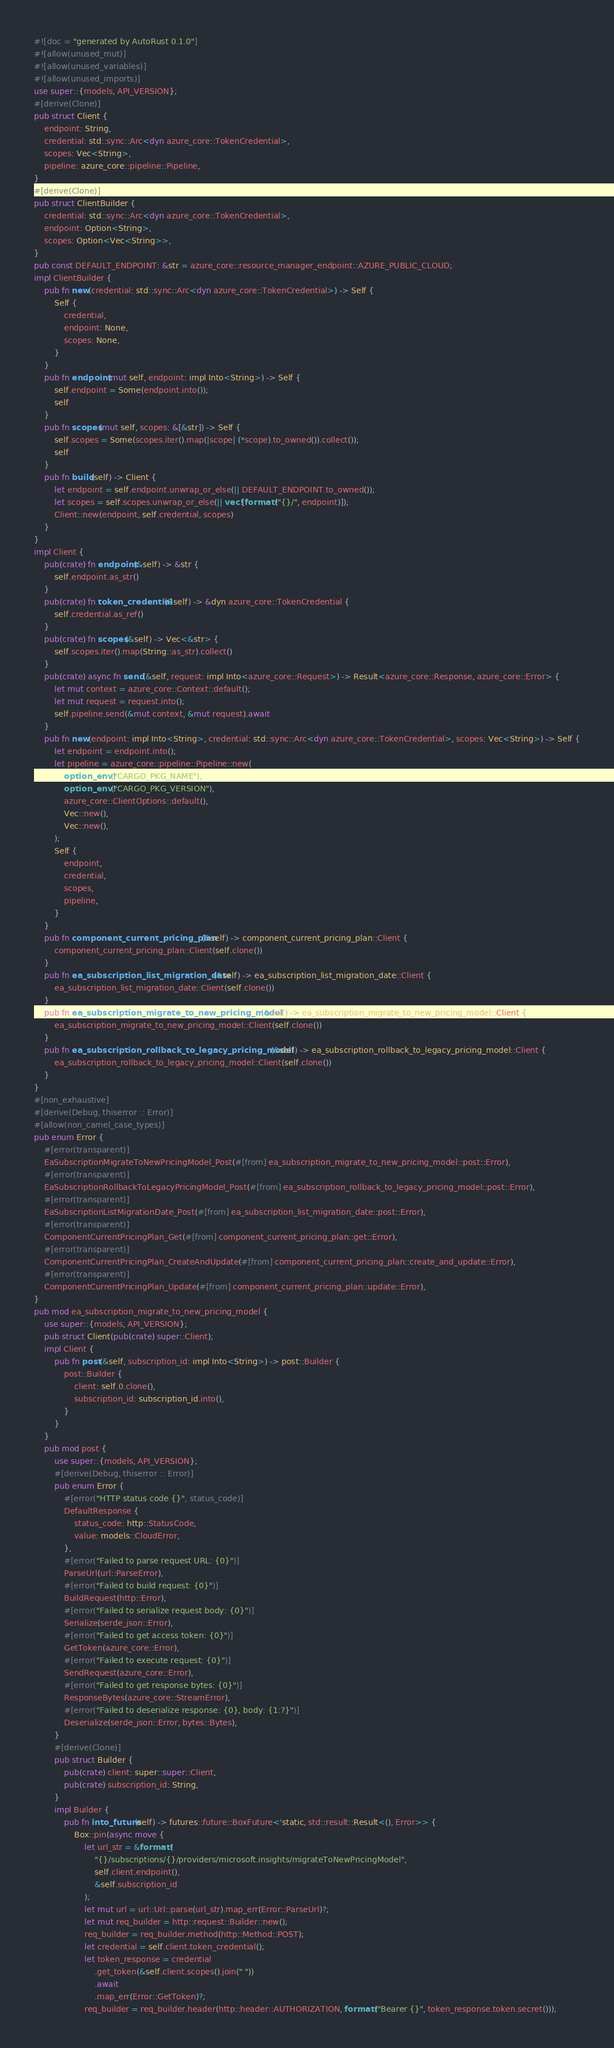<code> <loc_0><loc_0><loc_500><loc_500><_Rust_>#![doc = "generated by AutoRust 0.1.0"]
#![allow(unused_mut)]
#![allow(unused_variables)]
#![allow(unused_imports)]
use super::{models, API_VERSION};
#[derive(Clone)]
pub struct Client {
    endpoint: String,
    credential: std::sync::Arc<dyn azure_core::TokenCredential>,
    scopes: Vec<String>,
    pipeline: azure_core::pipeline::Pipeline,
}
#[derive(Clone)]
pub struct ClientBuilder {
    credential: std::sync::Arc<dyn azure_core::TokenCredential>,
    endpoint: Option<String>,
    scopes: Option<Vec<String>>,
}
pub const DEFAULT_ENDPOINT: &str = azure_core::resource_manager_endpoint::AZURE_PUBLIC_CLOUD;
impl ClientBuilder {
    pub fn new(credential: std::sync::Arc<dyn azure_core::TokenCredential>) -> Self {
        Self {
            credential,
            endpoint: None,
            scopes: None,
        }
    }
    pub fn endpoint(mut self, endpoint: impl Into<String>) -> Self {
        self.endpoint = Some(endpoint.into());
        self
    }
    pub fn scopes(mut self, scopes: &[&str]) -> Self {
        self.scopes = Some(scopes.iter().map(|scope| (*scope).to_owned()).collect());
        self
    }
    pub fn build(self) -> Client {
        let endpoint = self.endpoint.unwrap_or_else(|| DEFAULT_ENDPOINT.to_owned());
        let scopes = self.scopes.unwrap_or_else(|| vec![format!("{}/", endpoint)]);
        Client::new(endpoint, self.credential, scopes)
    }
}
impl Client {
    pub(crate) fn endpoint(&self) -> &str {
        self.endpoint.as_str()
    }
    pub(crate) fn token_credential(&self) -> &dyn azure_core::TokenCredential {
        self.credential.as_ref()
    }
    pub(crate) fn scopes(&self) -> Vec<&str> {
        self.scopes.iter().map(String::as_str).collect()
    }
    pub(crate) async fn send(&self, request: impl Into<azure_core::Request>) -> Result<azure_core::Response, azure_core::Error> {
        let mut context = azure_core::Context::default();
        let mut request = request.into();
        self.pipeline.send(&mut context, &mut request).await
    }
    pub fn new(endpoint: impl Into<String>, credential: std::sync::Arc<dyn azure_core::TokenCredential>, scopes: Vec<String>) -> Self {
        let endpoint = endpoint.into();
        let pipeline = azure_core::pipeline::Pipeline::new(
            option_env!("CARGO_PKG_NAME"),
            option_env!("CARGO_PKG_VERSION"),
            azure_core::ClientOptions::default(),
            Vec::new(),
            Vec::new(),
        );
        Self {
            endpoint,
            credential,
            scopes,
            pipeline,
        }
    }
    pub fn component_current_pricing_plan(&self) -> component_current_pricing_plan::Client {
        component_current_pricing_plan::Client(self.clone())
    }
    pub fn ea_subscription_list_migration_date(&self) -> ea_subscription_list_migration_date::Client {
        ea_subscription_list_migration_date::Client(self.clone())
    }
    pub fn ea_subscription_migrate_to_new_pricing_model(&self) -> ea_subscription_migrate_to_new_pricing_model::Client {
        ea_subscription_migrate_to_new_pricing_model::Client(self.clone())
    }
    pub fn ea_subscription_rollback_to_legacy_pricing_model(&self) -> ea_subscription_rollback_to_legacy_pricing_model::Client {
        ea_subscription_rollback_to_legacy_pricing_model::Client(self.clone())
    }
}
#[non_exhaustive]
#[derive(Debug, thiserror :: Error)]
#[allow(non_camel_case_types)]
pub enum Error {
    #[error(transparent)]
    EaSubscriptionMigrateToNewPricingModel_Post(#[from] ea_subscription_migrate_to_new_pricing_model::post::Error),
    #[error(transparent)]
    EaSubscriptionRollbackToLegacyPricingModel_Post(#[from] ea_subscription_rollback_to_legacy_pricing_model::post::Error),
    #[error(transparent)]
    EaSubscriptionListMigrationDate_Post(#[from] ea_subscription_list_migration_date::post::Error),
    #[error(transparent)]
    ComponentCurrentPricingPlan_Get(#[from] component_current_pricing_plan::get::Error),
    #[error(transparent)]
    ComponentCurrentPricingPlan_CreateAndUpdate(#[from] component_current_pricing_plan::create_and_update::Error),
    #[error(transparent)]
    ComponentCurrentPricingPlan_Update(#[from] component_current_pricing_plan::update::Error),
}
pub mod ea_subscription_migrate_to_new_pricing_model {
    use super::{models, API_VERSION};
    pub struct Client(pub(crate) super::Client);
    impl Client {
        pub fn post(&self, subscription_id: impl Into<String>) -> post::Builder {
            post::Builder {
                client: self.0.clone(),
                subscription_id: subscription_id.into(),
            }
        }
    }
    pub mod post {
        use super::{models, API_VERSION};
        #[derive(Debug, thiserror :: Error)]
        pub enum Error {
            #[error("HTTP status code {}", status_code)]
            DefaultResponse {
                status_code: http::StatusCode,
                value: models::CloudError,
            },
            #[error("Failed to parse request URL: {0}")]
            ParseUrl(url::ParseError),
            #[error("Failed to build request: {0}")]
            BuildRequest(http::Error),
            #[error("Failed to serialize request body: {0}")]
            Serialize(serde_json::Error),
            #[error("Failed to get access token: {0}")]
            GetToken(azure_core::Error),
            #[error("Failed to execute request: {0}")]
            SendRequest(azure_core::Error),
            #[error("Failed to get response bytes: {0}")]
            ResponseBytes(azure_core::StreamError),
            #[error("Failed to deserialize response: {0}, body: {1:?}")]
            Deserialize(serde_json::Error, bytes::Bytes),
        }
        #[derive(Clone)]
        pub struct Builder {
            pub(crate) client: super::super::Client,
            pub(crate) subscription_id: String,
        }
        impl Builder {
            pub fn into_future(self) -> futures::future::BoxFuture<'static, std::result::Result<(), Error>> {
                Box::pin(async move {
                    let url_str = &format!(
                        "{}/subscriptions/{}/providers/microsoft.insights/migrateToNewPricingModel",
                        self.client.endpoint(),
                        &self.subscription_id
                    );
                    let mut url = url::Url::parse(url_str).map_err(Error::ParseUrl)?;
                    let mut req_builder = http::request::Builder::new();
                    req_builder = req_builder.method(http::Method::POST);
                    let credential = self.client.token_credential();
                    let token_response = credential
                        .get_token(&self.client.scopes().join(" "))
                        .await
                        .map_err(Error::GetToken)?;
                    req_builder = req_builder.header(http::header::AUTHORIZATION, format!("Bearer {}", token_response.token.secret()));</code> 